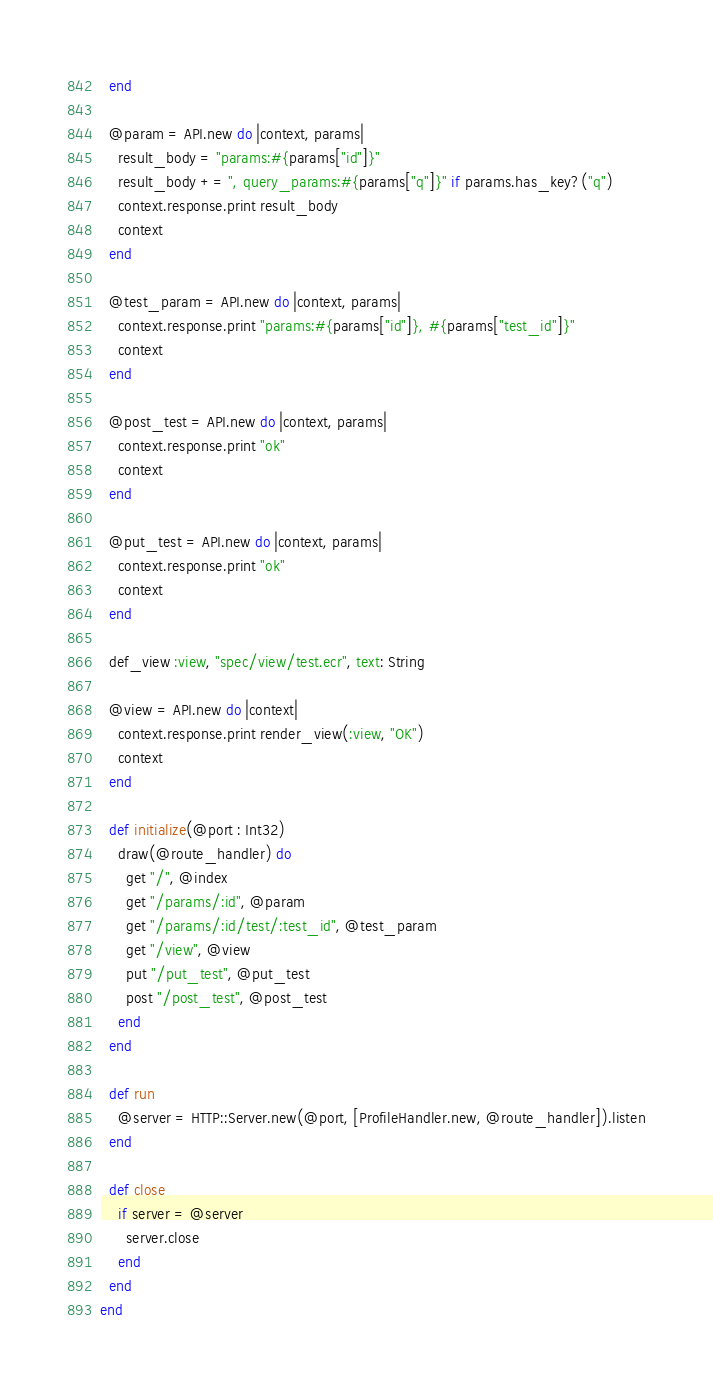Convert code to text. <code><loc_0><loc_0><loc_500><loc_500><_Crystal_>  end

  @param = API.new do |context, params|
    result_body = "params:#{params["id"]}"
    result_body += ", query_params:#{params["q"]}" if params.has_key?("q")
    context.response.print result_body
    context
  end

  @test_param = API.new do |context, params|
    context.response.print "params:#{params["id"]}, #{params["test_id"]}"
    context
  end

  @post_test = API.new do |context, params|
    context.response.print "ok"
    context
  end

  @put_test = API.new do |context, params|
    context.response.print "ok"
    context
  end

  def_view :view, "spec/view/test.ecr", text: String

  @view = API.new do |context|
    context.response.print render_view(:view, "OK")
    context
  end

  def initialize(@port : Int32)
    draw(@route_handler) do
      get "/", @index
      get "/params/:id", @param
      get "/params/:id/test/:test_id", @test_param
      get "/view", @view
      put "/put_test", @put_test
      post "/post_test", @post_test
    end
  end

  def run
    @server = HTTP::Server.new(@port, [ProfileHandler.new, @route_handler]).listen
  end

  def close
    if server = @server
      server.close
    end
  end
end
</code> 